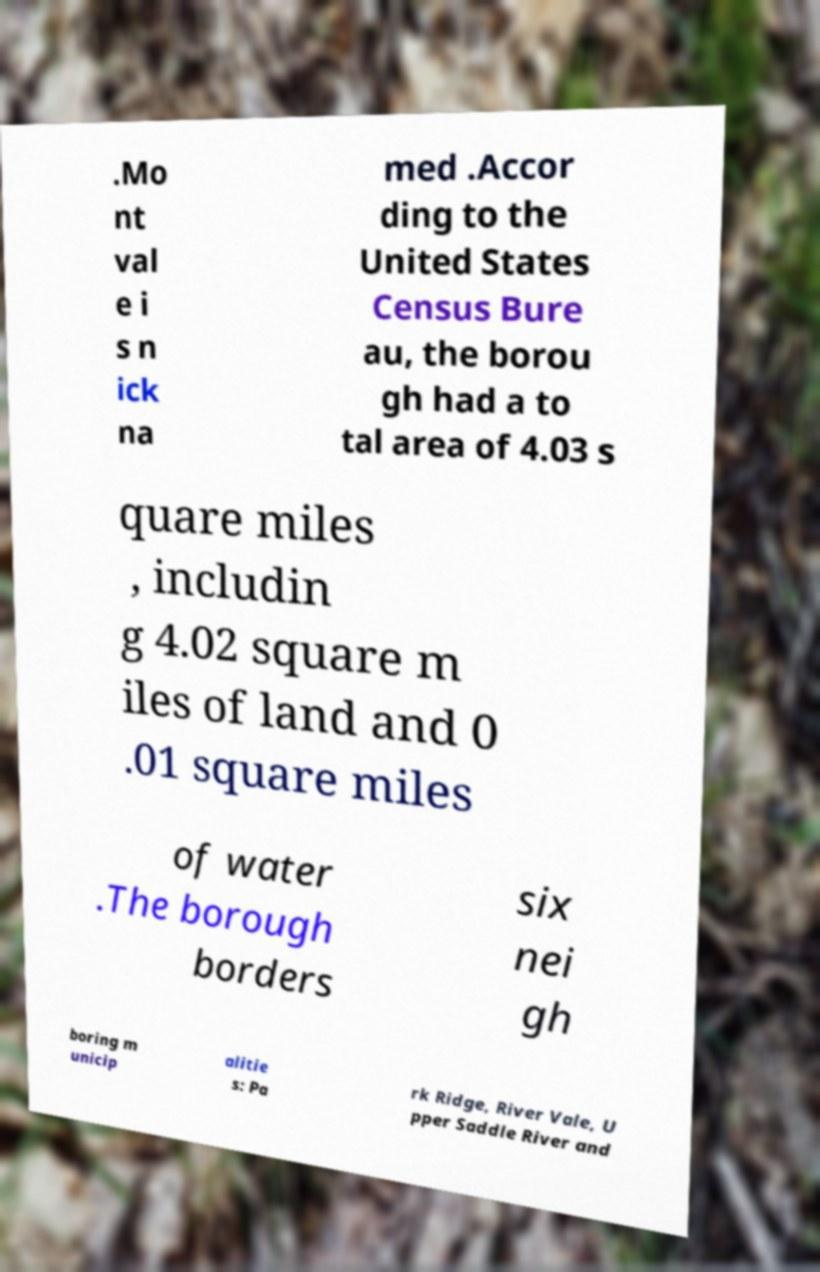There's text embedded in this image that I need extracted. Can you transcribe it verbatim? .Mo nt val e i s n ick na med .Accor ding to the United States Census Bure au, the borou gh had a to tal area of 4.03 s quare miles , includin g 4.02 square m iles of land and 0 .01 square miles of water .The borough borders six nei gh boring m unicip alitie s: Pa rk Ridge, River Vale, U pper Saddle River and 